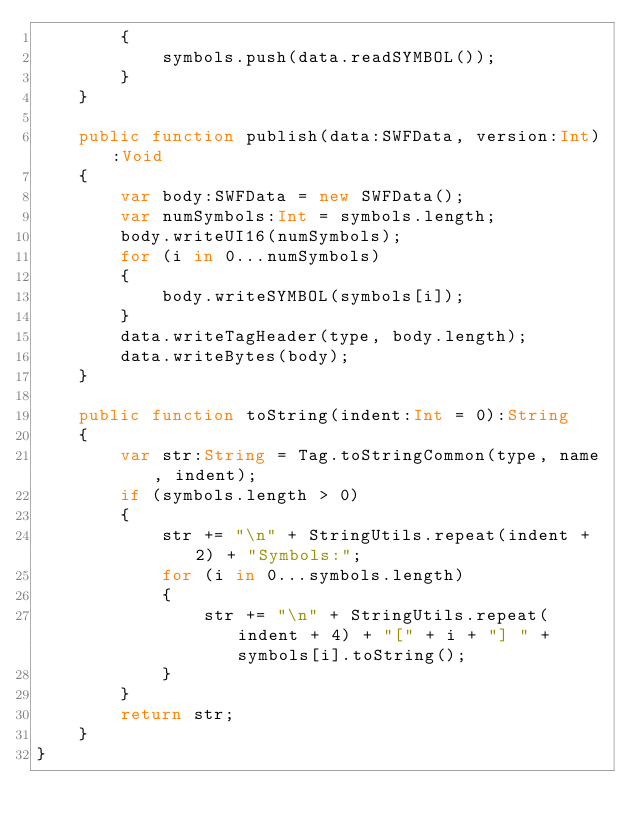<code> <loc_0><loc_0><loc_500><loc_500><_Haxe_>		{
			symbols.push(data.readSYMBOL());
		}
	}

	public function publish(data:SWFData, version:Int):Void
	{
		var body:SWFData = new SWFData();
		var numSymbols:Int = symbols.length;
		body.writeUI16(numSymbols);
		for (i in 0...numSymbols)
		{
			body.writeSYMBOL(symbols[i]);
		}
		data.writeTagHeader(type, body.length);
		data.writeBytes(body);
	}

	public function toString(indent:Int = 0):String
	{
		var str:String = Tag.toStringCommon(type, name, indent);
		if (symbols.length > 0)
		{
			str += "\n" + StringUtils.repeat(indent + 2) + "Symbols:";
			for (i in 0...symbols.length)
			{
				str += "\n" + StringUtils.repeat(indent + 4) + "[" + i + "] " + symbols[i].toString();
			}
		}
		return str;
	}
}
</code> 